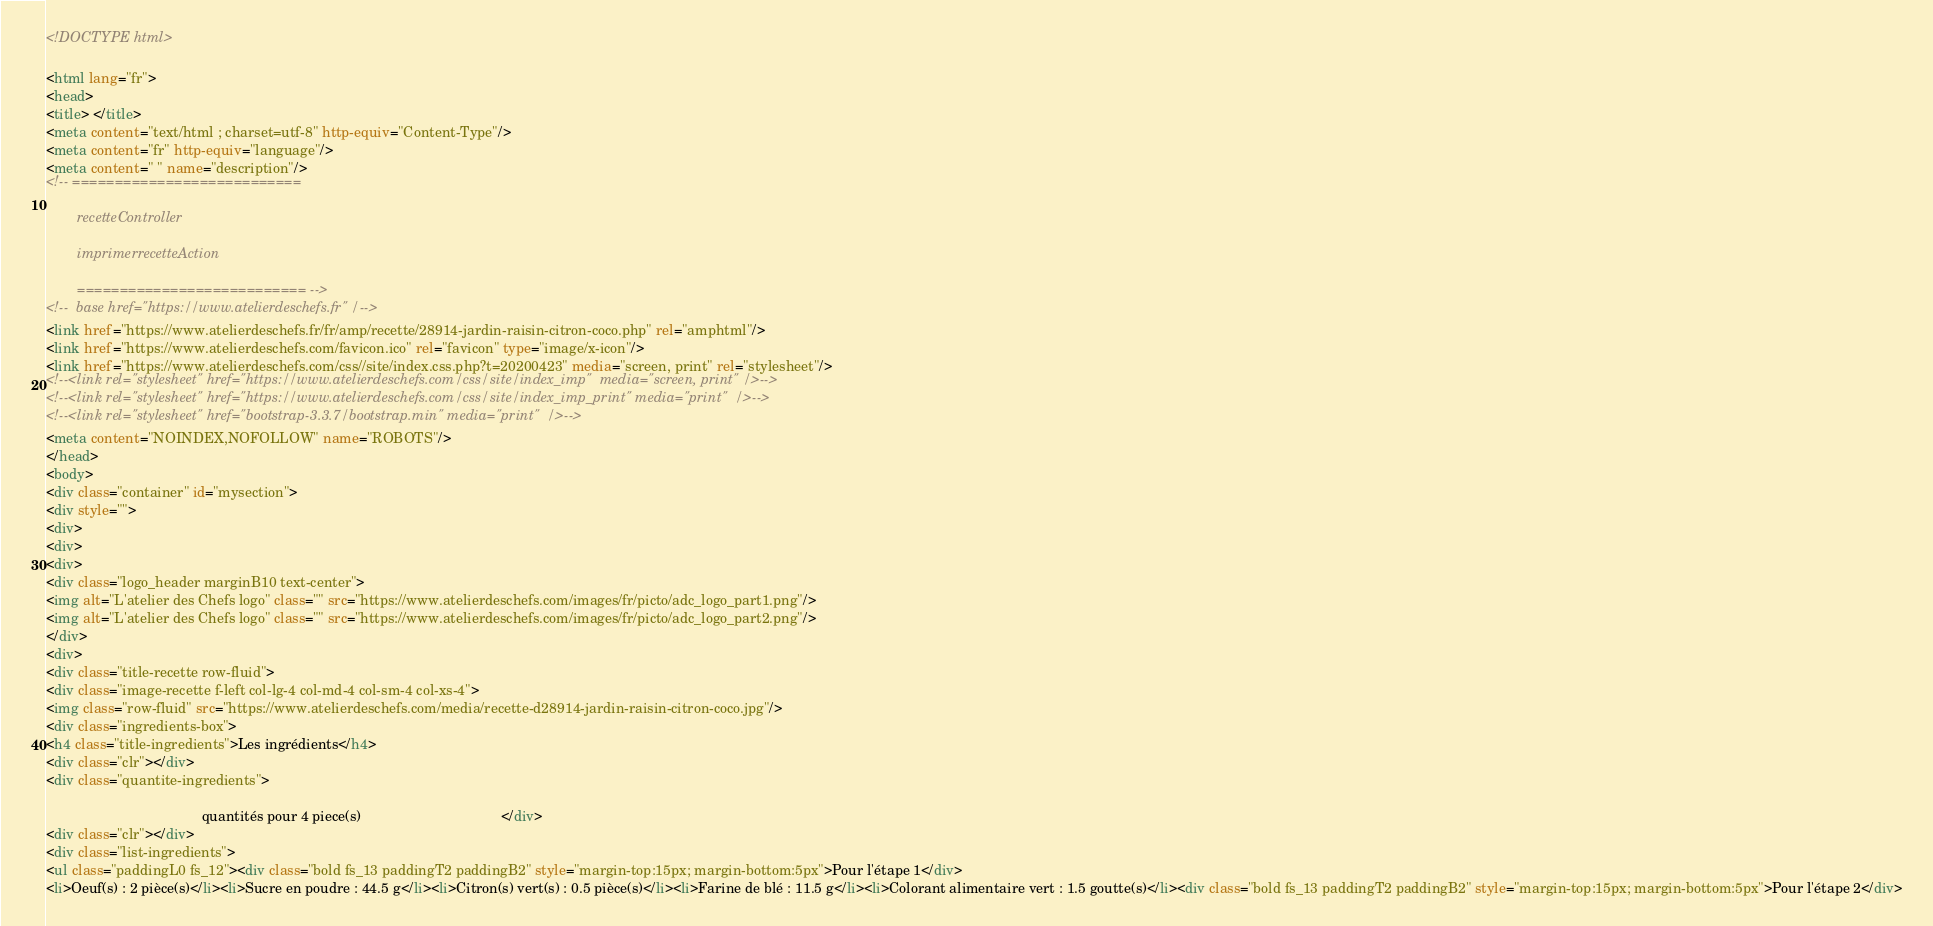Convert code to text. <code><loc_0><loc_0><loc_500><loc_500><_HTML_>
<!DOCTYPE html>

<html lang="fr">
<head>
<title> </title>
<meta content="text/html ; charset=utf-8" http-equiv="Content-Type"/>
<meta content="fr" http-equiv="language"/>
<meta content=" " name="description"/>
<!-- ===========================
        recetteController
        imprimerrecetteAction
        =========================== -->
<!--  base href="https://www.atelierdeschefs.fr" /-->
<link href="https://www.atelierdeschefs.fr/fr/amp/recette/28914-jardin-raisin-citron-coco.php" rel="amphtml"/>
<link href="https://www.atelierdeschefs.com/favicon.ico" rel="favicon" type="image/x-icon"/>
<link href="https://www.atelierdeschefs.com/css//site/index.css.php?t=20200423" media="screen, print" rel="stylesheet"/>
<!--<link rel="stylesheet" href="https://www.atelierdeschefs.com/css/site/index_imp"  media="screen, print" />-->
<!--<link rel="stylesheet" href="https://www.atelierdeschefs.com/css/site/index_imp_print" media="print"  />-->
<!--<link rel="stylesheet" href="bootstrap-3.3.7/bootstrap.min" media="print"  />-->
<meta content="NOINDEX,NOFOLLOW" name="ROBOTS"/>
</head>
<body>
<div class="container" id="mysection">
<div style="">
<div>
<div>
<div>
<div class="logo_header marginB10 text-center">
<img alt="L'atelier des Chefs logo" class="" src="https://www.atelierdeschefs.com/images/fr/picto/adc_logo_part1.png"/>
<img alt="L'atelier des Chefs logo" class="" src="https://www.atelierdeschefs.com/images/fr/picto/adc_logo_part2.png"/>
</div>
<div>
<div class="title-recette row-fluid">
<div class="image-recette f-left col-lg-4 col-md-4 col-sm-4 col-xs-4">
<img class="row-fluid" src="https://www.atelierdeschefs.com/media/recette-d28914-jardin-raisin-citron-coco.jpg"/>
<div class="ingredients-box">
<h4 class="title-ingredients">Les ingrédients</h4>
<div class="clr"></div>
<div class="quantite-ingredients">
                                        quantités pour 4 piece(s)                                    </div>
<div class="clr"></div>
<div class="list-ingredients">
<ul class="paddingL0 fs_12"><div class="bold fs_13 paddingT2 paddingB2" style="margin-top:15px; margin-bottom:5px">Pour l'étape 1</div>
<li>Oeuf(s) : 2 pièce(s)</li><li>Sucre en poudre : 44.5 g</li><li>Citron(s) vert(s) : 0.5 pièce(s)</li><li>Farine de blé : 11.5 g</li><li>Colorant alimentaire vert : 1.5 goutte(s)</li><div class="bold fs_13 paddingT2 paddingB2" style="margin-top:15px; margin-bottom:5px">Pour l'étape 2</div></code> 